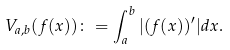Convert formula to latex. <formula><loc_0><loc_0><loc_500><loc_500>V _ { a , b } ( f ( x ) ) \colon = \int _ { a } ^ { b } | ( f ( x ) ) ^ { \prime } | d x .</formula> 